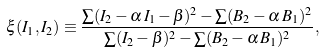Convert formula to latex. <formula><loc_0><loc_0><loc_500><loc_500>\xi ( I _ { 1 } , I _ { 2 } ) \equiv \frac { \sum ( I _ { 2 } - \alpha \, I _ { 1 } - \beta ) ^ { 2 } - \sum ( B _ { 2 } - \alpha \, B _ { 1 } ) ^ { 2 } } { \sum ( I _ { 2 } - \beta ) ^ { 2 } - \sum ( B _ { 2 } - \alpha \, B _ { 1 } ) ^ { 2 } } ,</formula> 